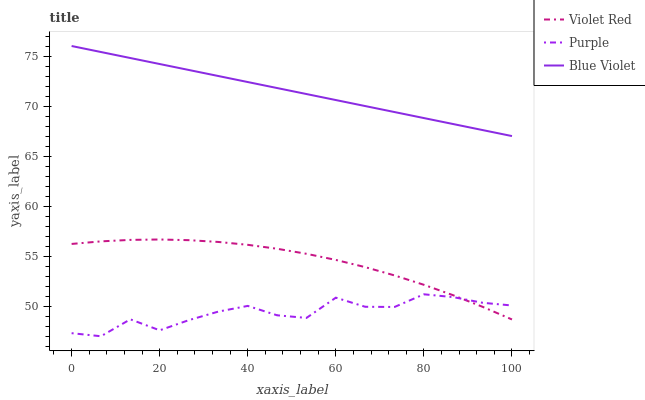Does Violet Red have the minimum area under the curve?
Answer yes or no. No. Does Violet Red have the maximum area under the curve?
Answer yes or no. No. Is Violet Red the smoothest?
Answer yes or no. No. Is Violet Red the roughest?
Answer yes or no. No. Does Violet Red have the lowest value?
Answer yes or no. No. Does Violet Red have the highest value?
Answer yes or no. No. Is Purple less than Blue Violet?
Answer yes or no. Yes. Is Blue Violet greater than Violet Red?
Answer yes or no. Yes. Does Purple intersect Blue Violet?
Answer yes or no. No. 